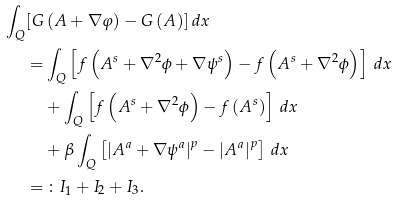<formula> <loc_0><loc_0><loc_500><loc_500>\int _ { Q } [ G & \left ( A + \nabla \varphi \right ) - G \left ( A \right ) ] \, d x \\ = & \int _ { Q } \left [ f \left ( A ^ { s } + \nabla ^ { 2 } \phi + \nabla \psi ^ { s } \right ) - f \left ( A ^ { s } + \nabla ^ { 2 } \phi \right ) \right ] \, d x \\ & + \int _ { Q } \left [ f \left ( A ^ { s } + \nabla ^ { 2 } \phi \right ) - f \left ( A ^ { s } \right ) \right ] \, d x \\ & + \beta \int _ { Q } \left [ \left | A ^ { a } + \nabla \psi ^ { a } \right | ^ { p } - \left | A ^ { a } \right | ^ { p } \right ] \, d x \\ = & \, \colon I _ { 1 } + I _ { 2 } + I _ { 3 } .</formula> 